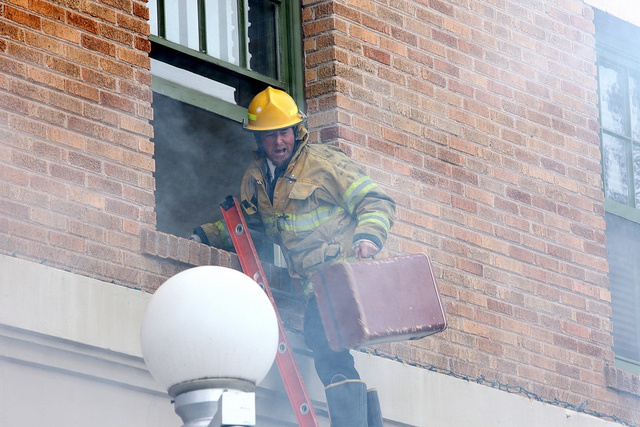Describe the objects in this image and their specific colors. I can see people in brown, darkgray, and gray tones, suitcase in brown, darkgray, and gray tones, and tie in brown, darkblue, blue, gray, and darkgray tones in this image. 